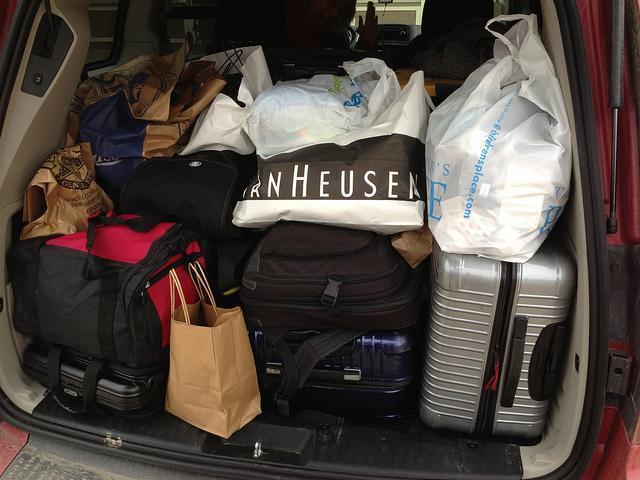What most likely happened before this?
Choose the right answer from the provided options to respond to the question.
Options: Shopping, biking, swimming, hiking. Shopping. 